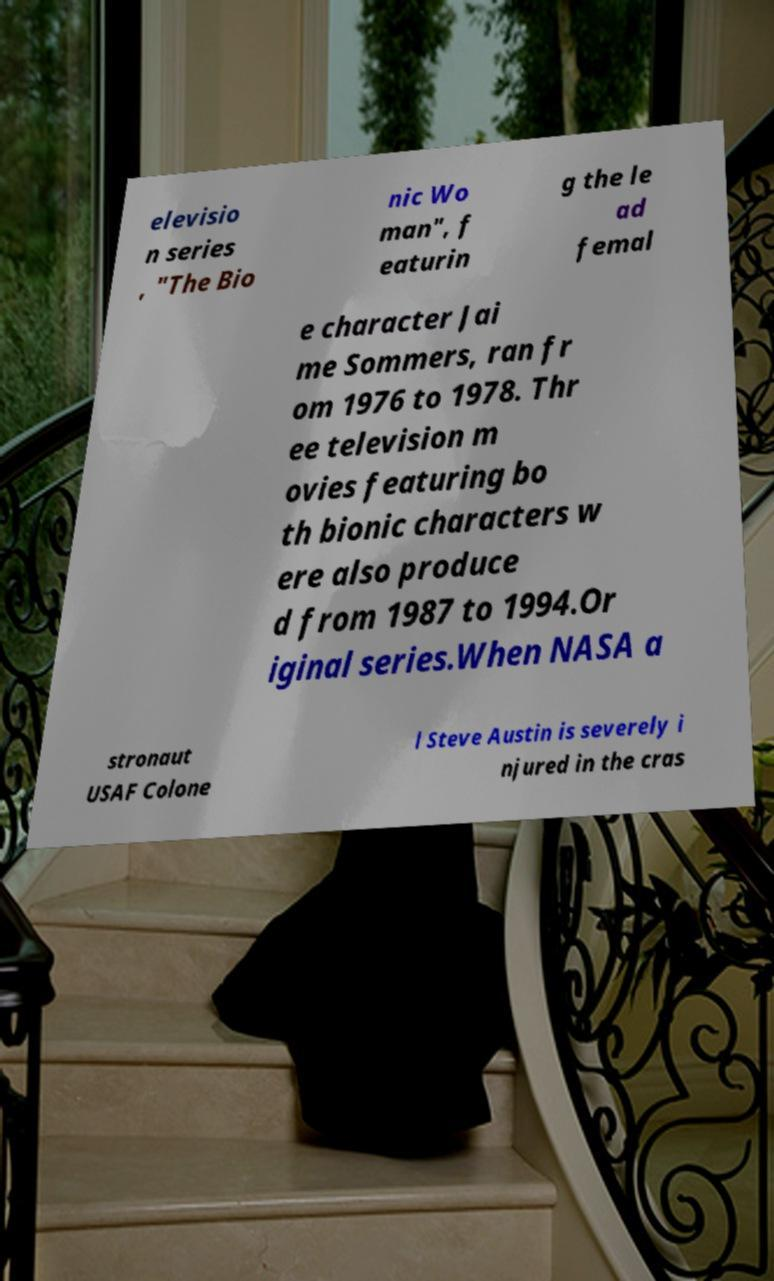Can you read and provide the text displayed in the image?This photo seems to have some interesting text. Can you extract and type it out for me? elevisio n series , "The Bio nic Wo man", f eaturin g the le ad femal e character Jai me Sommers, ran fr om 1976 to 1978. Thr ee television m ovies featuring bo th bionic characters w ere also produce d from 1987 to 1994.Or iginal series.When NASA a stronaut USAF Colone l Steve Austin is severely i njured in the cras 